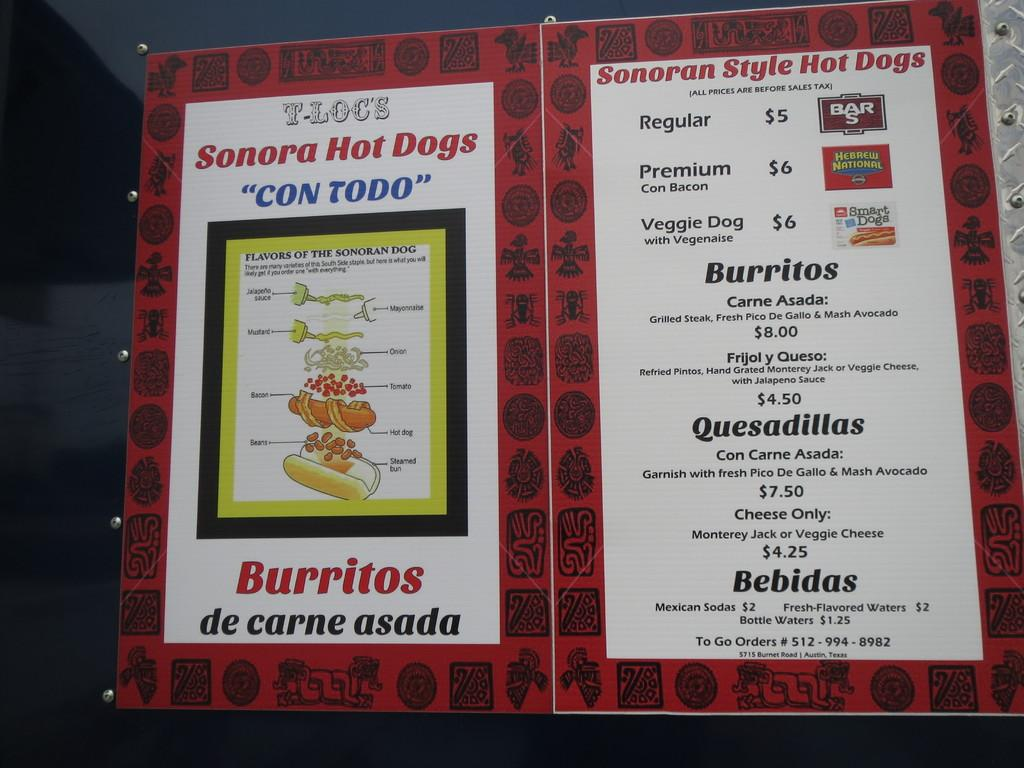Provide a one-sentence caption for the provided image. A menu featuring a Sonora Hot Dogs and Burritos. 